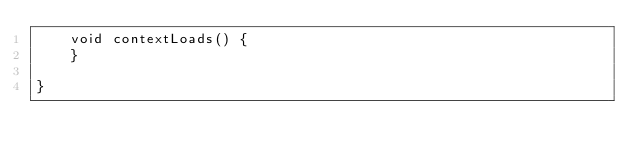Convert code to text. <code><loc_0><loc_0><loc_500><loc_500><_Java_>    void contextLoads() {
    }

}
</code> 